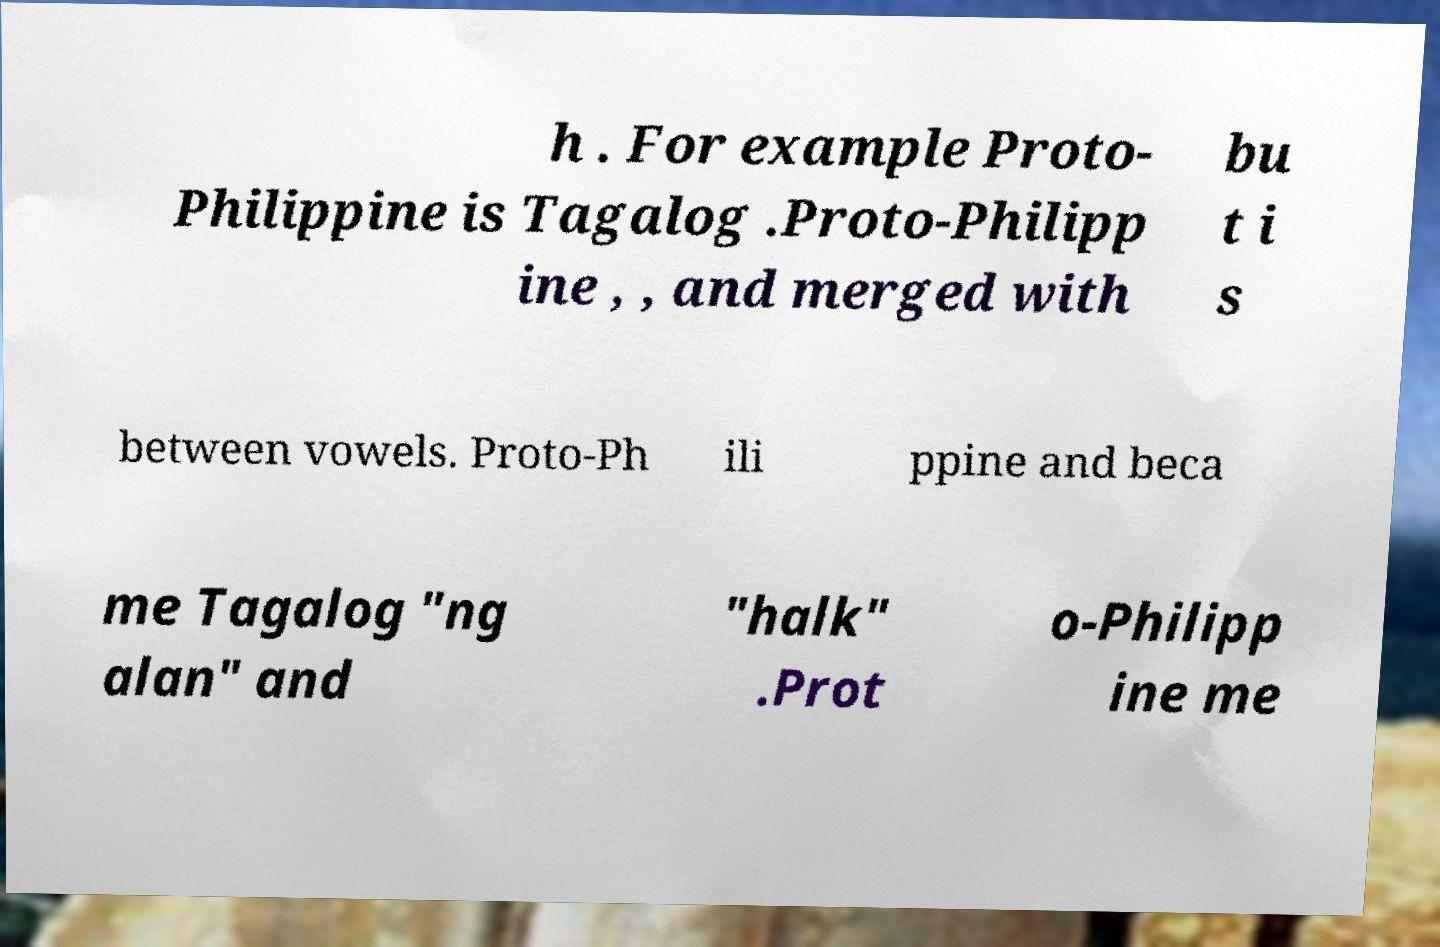What messages or text are displayed in this image? I need them in a readable, typed format. h . For example Proto- Philippine is Tagalog .Proto-Philipp ine , , and merged with bu t i s between vowels. Proto-Ph ili ppine and beca me Tagalog "ng alan" and "halk" .Prot o-Philipp ine me 